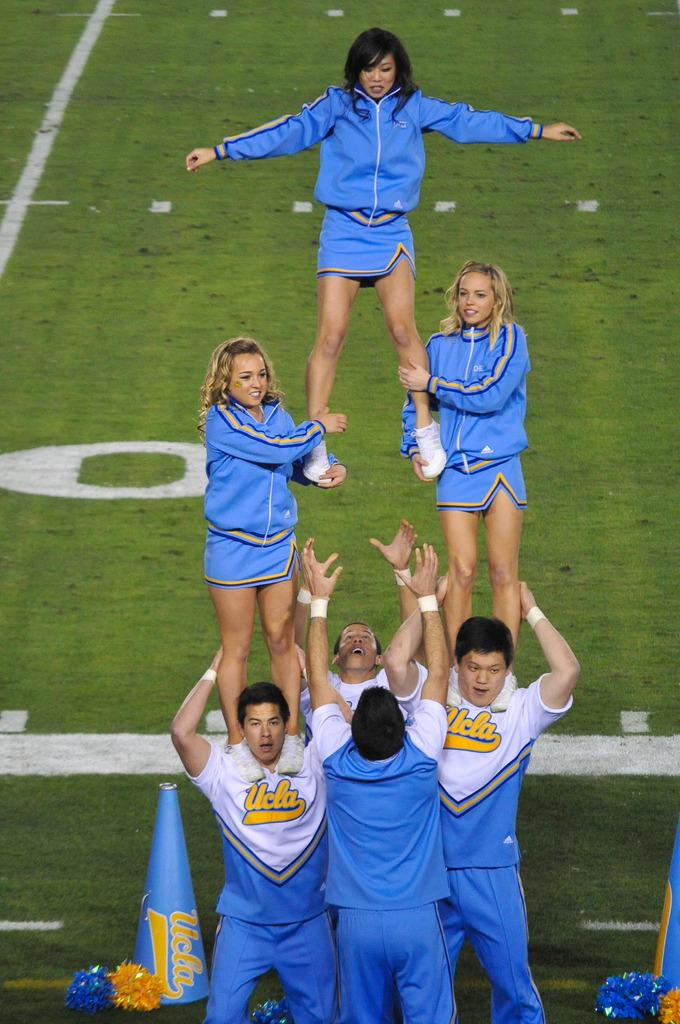<image>
Give a short and clear explanation of the subsequent image. some cheerleaders with UCLA on their blue uniforms 